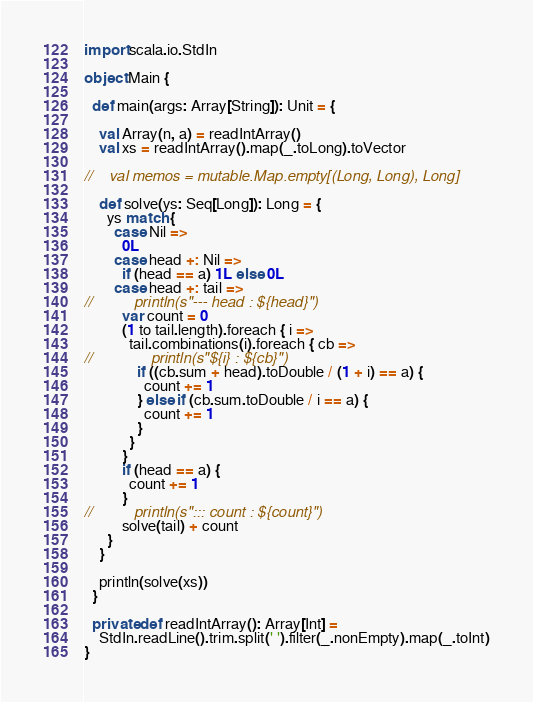<code> <loc_0><loc_0><loc_500><loc_500><_Scala_>import scala.io.StdIn

object Main {

  def main(args: Array[String]): Unit = {

    val Array(n, a) = readIntArray()
    val xs = readIntArray().map(_.toLong).toVector

//    val memos = mutable.Map.empty[(Long, Long), Long]

    def solve(ys: Seq[Long]): Long = {
      ys match {
        case Nil =>
          0L
        case head +: Nil =>
          if (head == a) 1L else 0L
        case head +: tail =>
//          println(s"--- head : ${head}")
          var count = 0
          (1 to tail.length).foreach { i =>
            tail.combinations(i).foreach { cb =>
//              println(s"${i} : ${cb}")
              if ((cb.sum + head).toDouble / (1 + i) == a) {
                count += 1
              } else if (cb.sum.toDouble / i == a) {
                count += 1
              }
            }
          }
          if (head == a) {
            count += 1
          }
//          println(s"::: count : ${count}")
          solve(tail) + count
      }
    }

    println(solve(xs))
  }

  private def readIntArray(): Array[Int] =
    StdIn.readLine().trim.split(' ').filter(_.nonEmpty).map(_.toInt)
}
</code> 